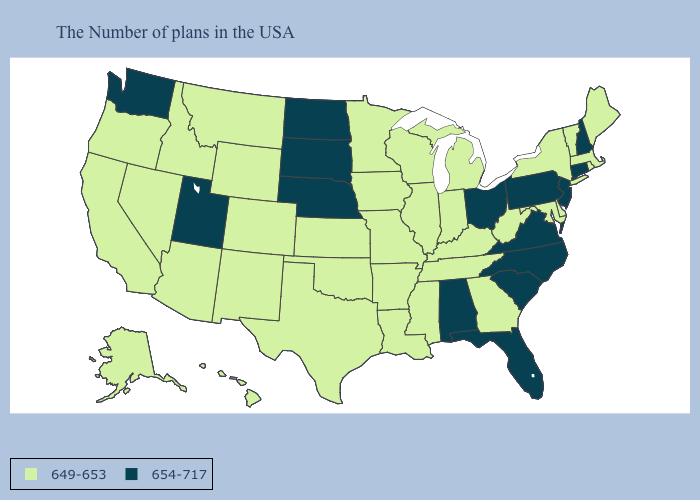Name the states that have a value in the range 649-653?
Give a very brief answer. Maine, Massachusetts, Rhode Island, Vermont, New York, Delaware, Maryland, West Virginia, Georgia, Michigan, Kentucky, Indiana, Tennessee, Wisconsin, Illinois, Mississippi, Louisiana, Missouri, Arkansas, Minnesota, Iowa, Kansas, Oklahoma, Texas, Wyoming, Colorado, New Mexico, Montana, Arizona, Idaho, Nevada, California, Oregon, Alaska, Hawaii. Among the states that border Vermont , does New Hampshire have the highest value?
Write a very short answer. Yes. What is the value of Michigan?
Answer briefly. 649-653. Among the states that border Mississippi , does Alabama have the lowest value?
Answer briefly. No. What is the highest value in the Northeast ?
Concise answer only. 654-717. What is the value of New Mexico?
Give a very brief answer. 649-653. Name the states that have a value in the range 654-717?
Answer briefly. New Hampshire, Connecticut, New Jersey, Pennsylvania, Virginia, North Carolina, South Carolina, Ohio, Florida, Alabama, Nebraska, South Dakota, North Dakota, Utah, Washington. What is the value of Colorado?
Keep it brief. 649-653. Among the states that border Wyoming , which have the lowest value?
Quick response, please. Colorado, Montana, Idaho. How many symbols are there in the legend?
Quick response, please. 2. Which states have the lowest value in the USA?
Concise answer only. Maine, Massachusetts, Rhode Island, Vermont, New York, Delaware, Maryland, West Virginia, Georgia, Michigan, Kentucky, Indiana, Tennessee, Wisconsin, Illinois, Mississippi, Louisiana, Missouri, Arkansas, Minnesota, Iowa, Kansas, Oklahoma, Texas, Wyoming, Colorado, New Mexico, Montana, Arizona, Idaho, Nevada, California, Oregon, Alaska, Hawaii. Name the states that have a value in the range 654-717?
Write a very short answer. New Hampshire, Connecticut, New Jersey, Pennsylvania, Virginia, North Carolina, South Carolina, Ohio, Florida, Alabama, Nebraska, South Dakota, North Dakota, Utah, Washington. What is the value of California?
Keep it brief. 649-653. What is the value of Nebraska?
Keep it brief. 654-717. Does Oklahoma have the lowest value in the South?
Be succinct. Yes. 